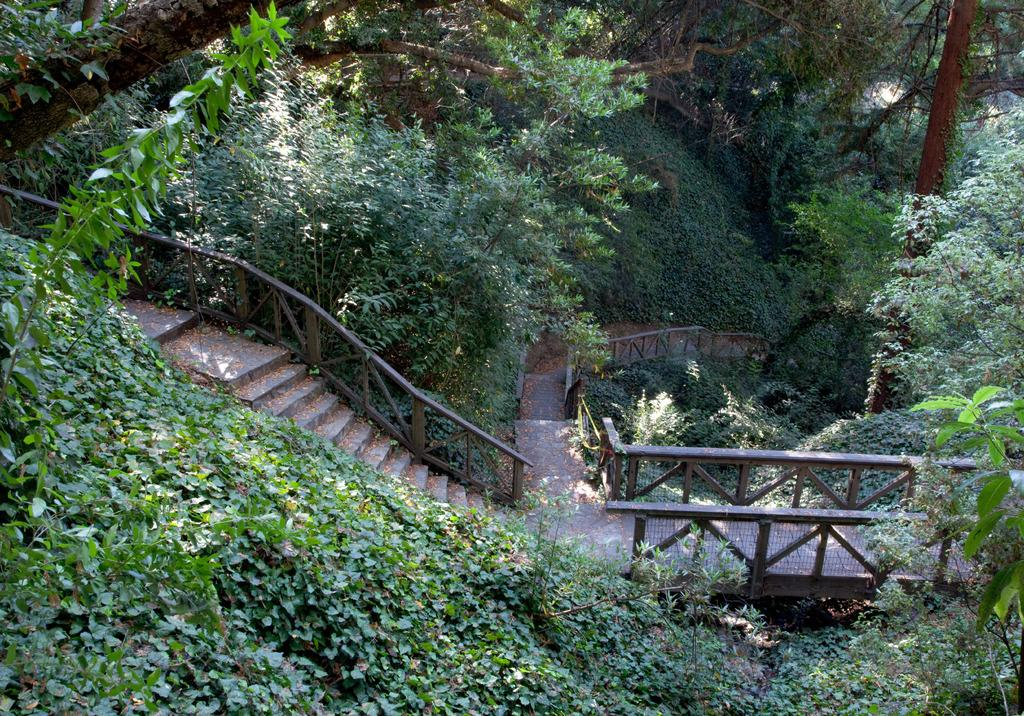What type of structure can be seen in the image? There are stairs in the image. What is the purpose of the structure next to the stairs? There is a fence in the image. What type of ground surface is visible in the image? There is grass in the image. What type of vegetation can be seen in the image? There are trees in the image. What type of joke can be seen hanging from the trees in the image? There are no jokes present in the image; it features stairs, a fence, grass, and trees. What is the mass of the icicle hanging from the fence in the image? There is no icicle present in the image, so its mass cannot be determined. 